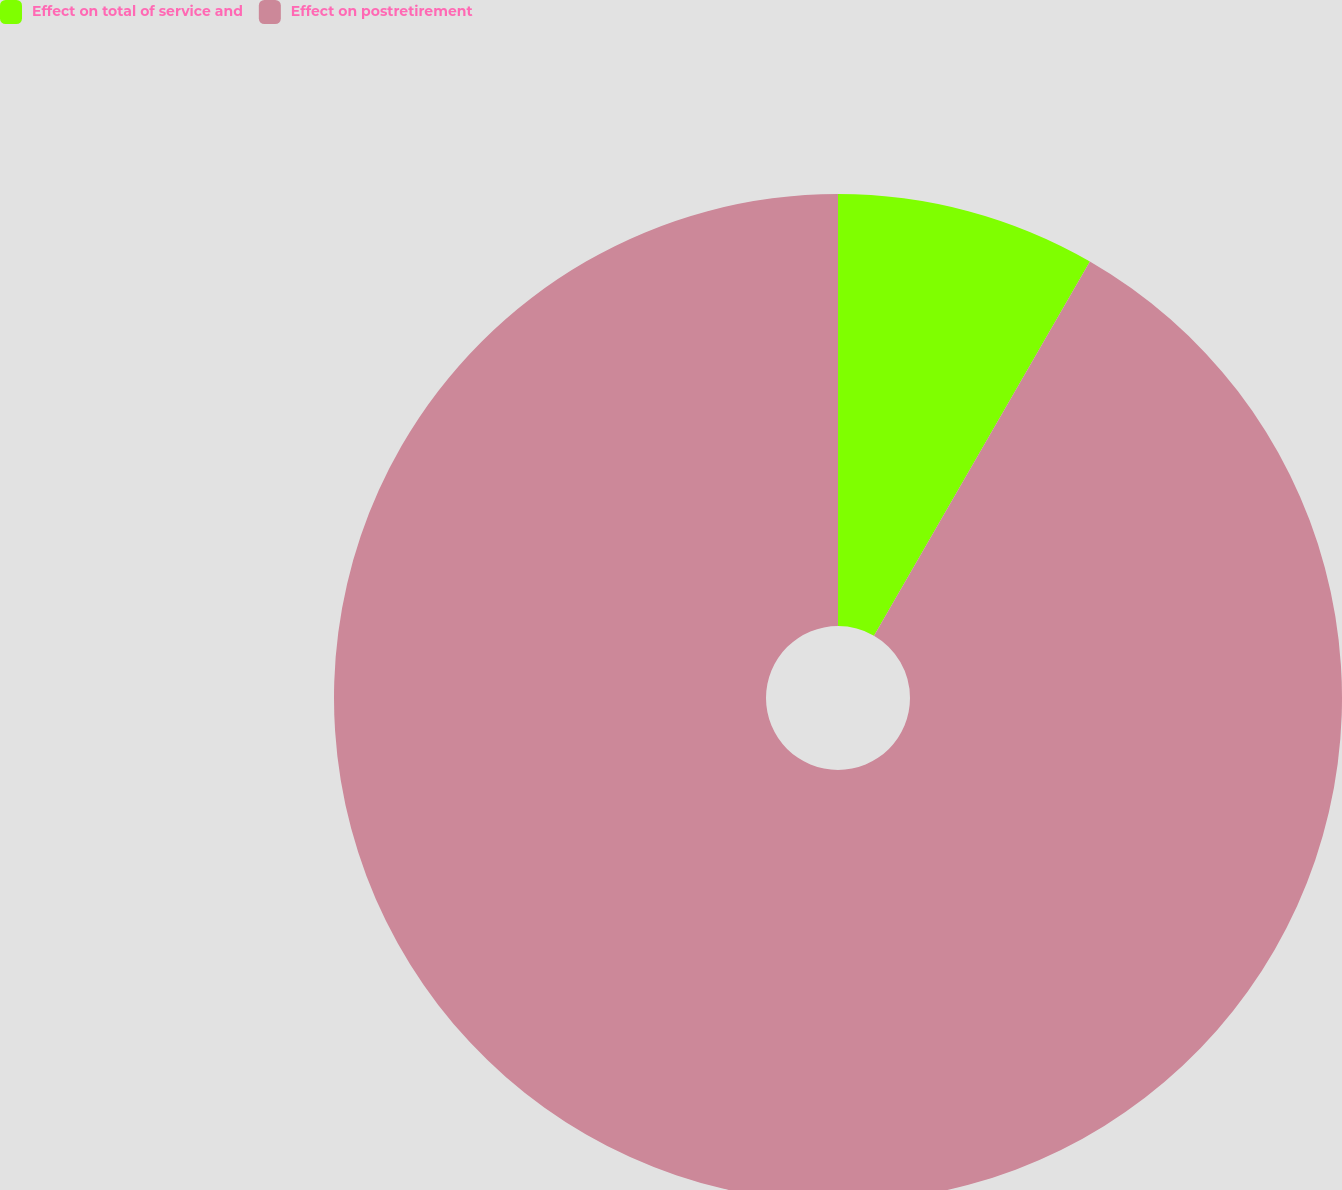<chart> <loc_0><loc_0><loc_500><loc_500><pie_chart><fcel>Effect on total of service and<fcel>Effect on postretirement<nl><fcel>8.33%<fcel>91.67%<nl></chart> 